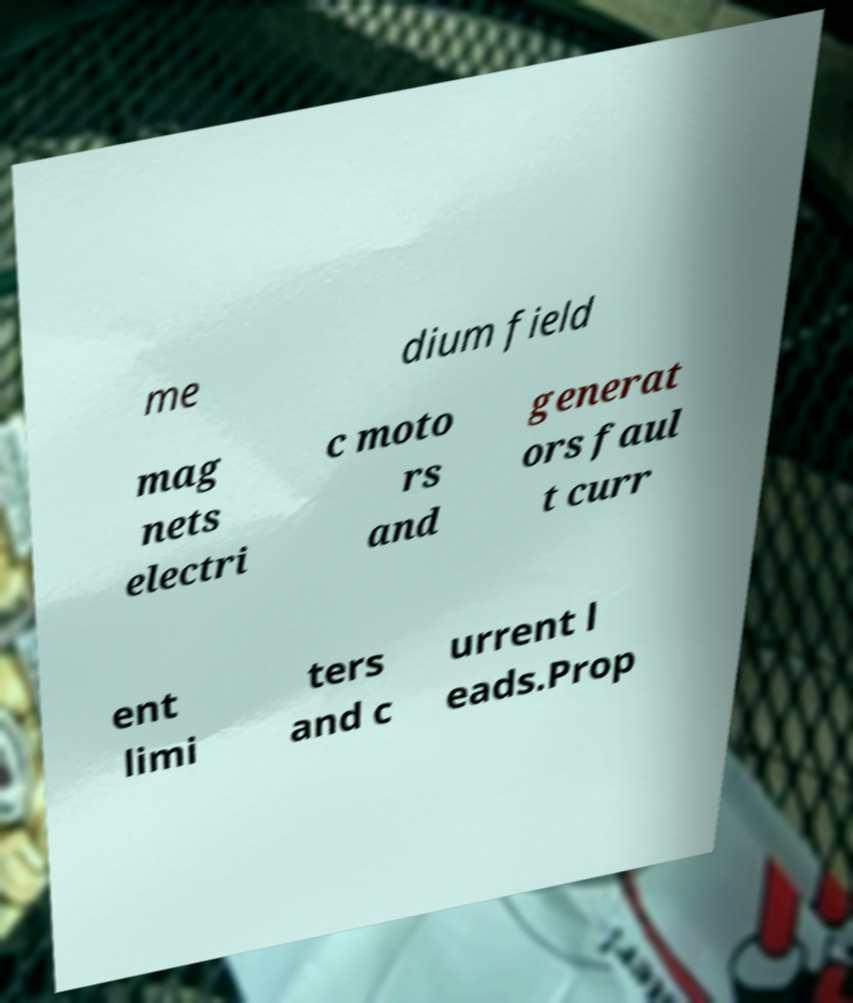Can you read and provide the text displayed in the image?This photo seems to have some interesting text. Can you extract and type it out for me? me dium field mag nets electri c moto rs and generat ors faul t curr ent limi ters and c urrent l eads.Prop 